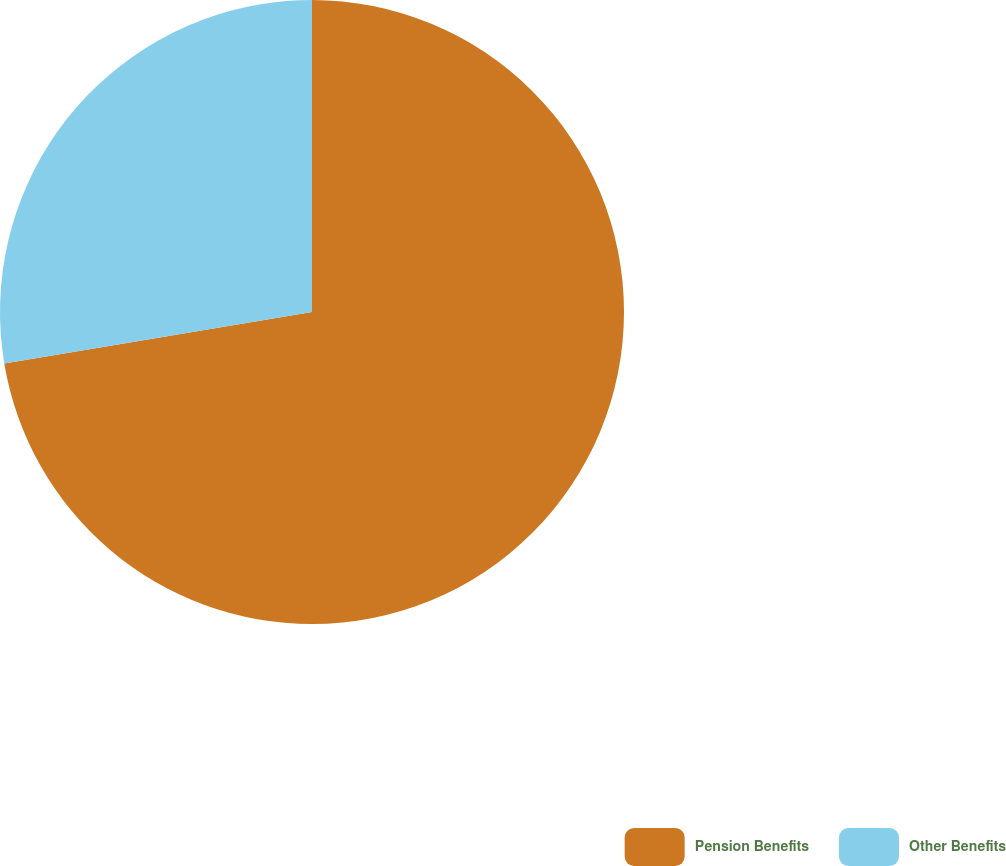Convert chart to OTSL. <chart><loc_0><loc_0><loc_500><loc_500><pie_chart><fcel>Pension Benefits<fcel>Other Benefits<nl><fcel>72.36%<fcel>27.64%<nl></chart> 